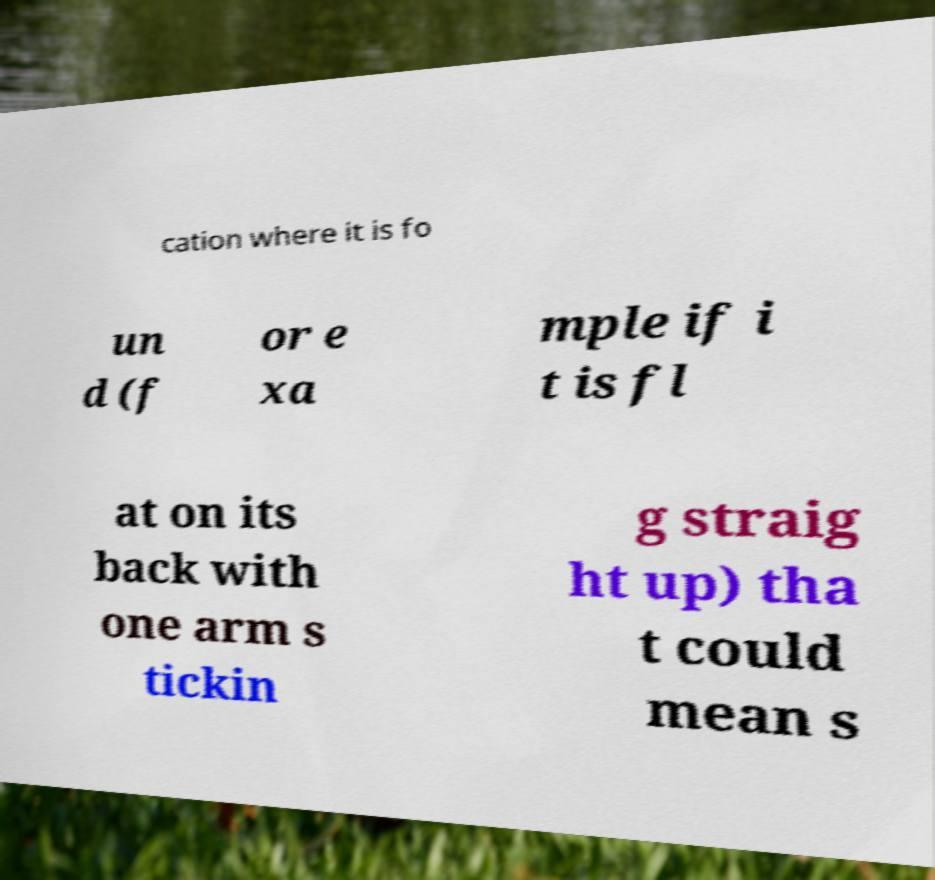For documentation purposes, I need the text within this image transcribed. Could you provide that? cation where it is fo un d (f or e xa mple if i t is fl at on its back with one arm s tickin g straig ht up) tha t could mean s 